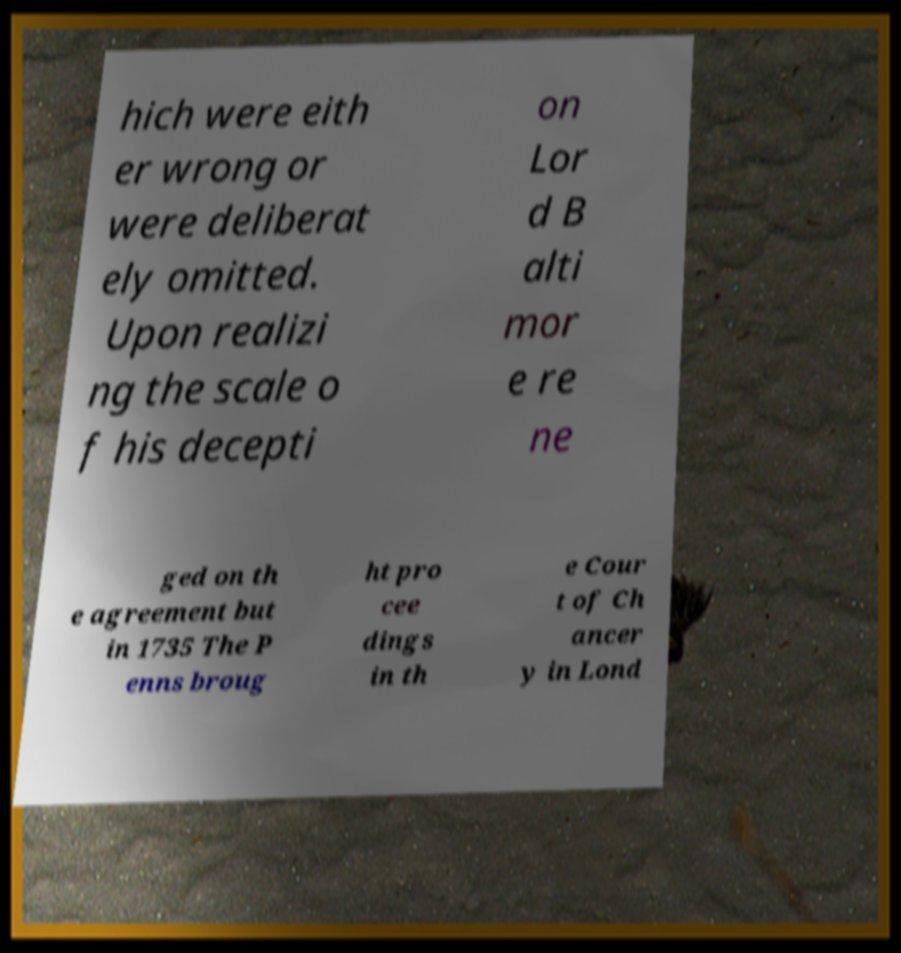Can you read and provide the text displayed in the image?This photo seems to have some interesting text. Can you extract and type it out for me? hich were eith er wrong or were deliberat ely omitted. Upon realizi ng the scale o f his decepti on Lor d B alti mor e re ne ged on th e agreement but in 1735 The P enns broug ht pro cee dings in th e Cour t of Ch ancer y in Lond 